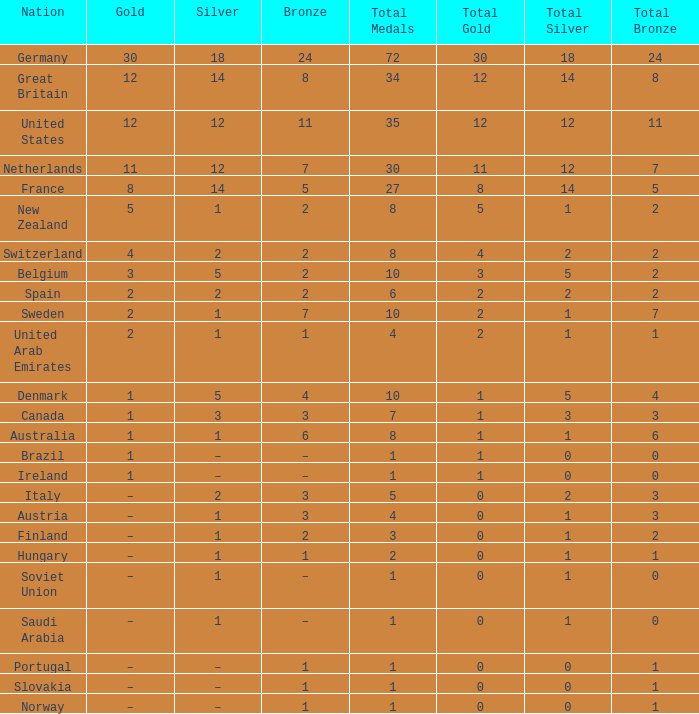What does gold represent, when bronze equals 11? 12.0. 